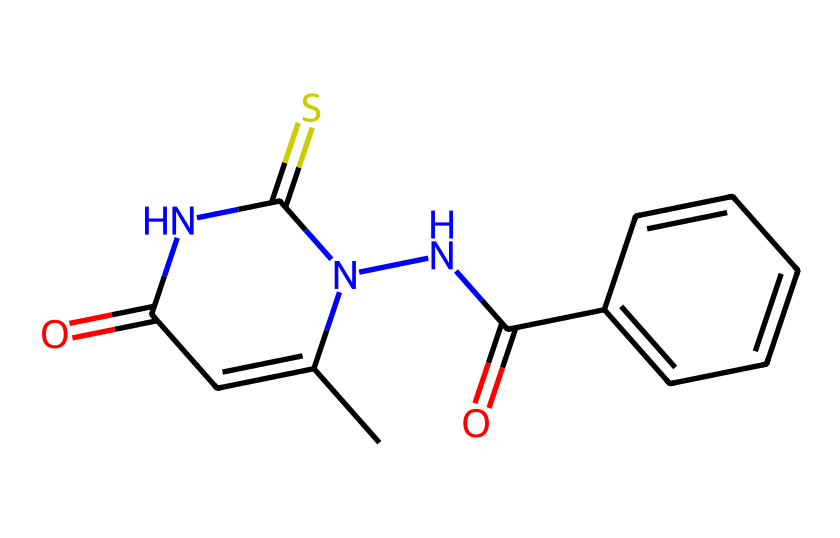What is the total number of nitrogen atoms in this compound? By inspecting the chemical structure encoded by the SMILES representation, I can see that there are three distinct nitrogen atoms represented by the letter 'N'.
Answer: 3 How many aromatic rings are present in this chemical? The chemical structure shows a benzene ring, characterized by alternating double bonds. It is represented in the SMILES by the 'c' characters. There is only one aromatic ring in this compound.
Answer: 1 What functional groups are present in this chemical? Analyzing the structure, I notice the presence of a thiourea group (C(=S)N) and an amide group (C(=O)N). These groups are key indicators of the chemical's functionality.
Answer: thiourea and amide Which part of this chemical contributes to its color-forming property? The presence of multiple conjugated systems, particularly through the aromatic ring with the adjacent nitrogen and carbonyl groups, facilitates the formation of color. The overall arrangement allows for electron delocalization, which is essential for color formation in dyes.
Answer: conjugated systems What is the molecular weight of this compound? To find the molecular weight, I sum the individual atomic weights of all the atoms present in the SMILES representation, accounting for carbon, hydrogen, nitrogen, oxygen, and sulfur. The total weight calculated is 222.25 g/mol.
Answer: 222.25 Which elements in the molecule are most reactive due to their positioning? The nitrogen atoms are positioned in a way that suggests they are involved in nucleophilic reactions. Their proximity to the reactive carbonyl and thiourea groups makes them particularly reactive in this compound.
Answer: nitrogen atoms 